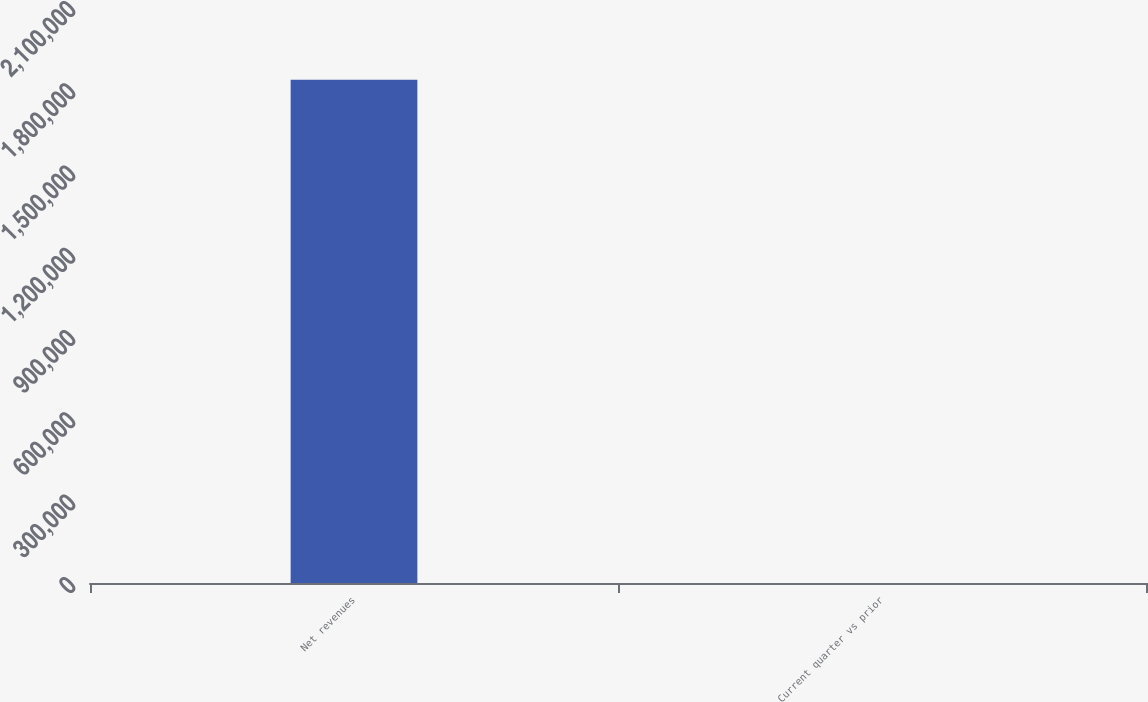<chart> <loc_0><loc_0><loc_500><loc_500><bar_chart><fcel>Net revenues<fcel>Current quarter vs prior<nl><fcel>1.83443e+06<fcel>4<nl></chart> 